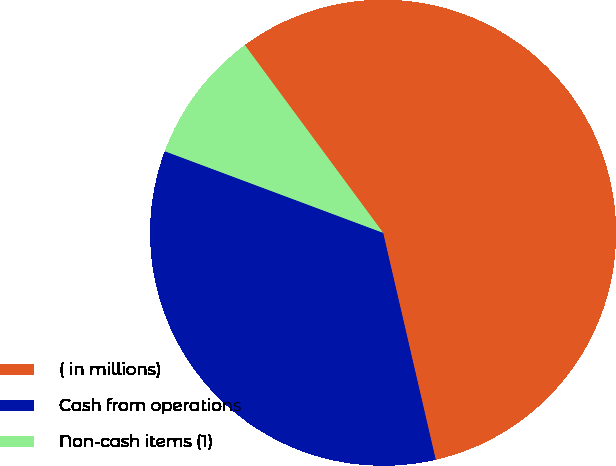Convert chart. <chart><loc_0><loc_0><loc_500><loc_500><pie_chart><fcel>( in millions)<fcel>Cash from operations<fcel>Non-cash items (1)<nl><fcel>56.48%<fcel>34.32%<fcel>9.2%<nl></chart> 